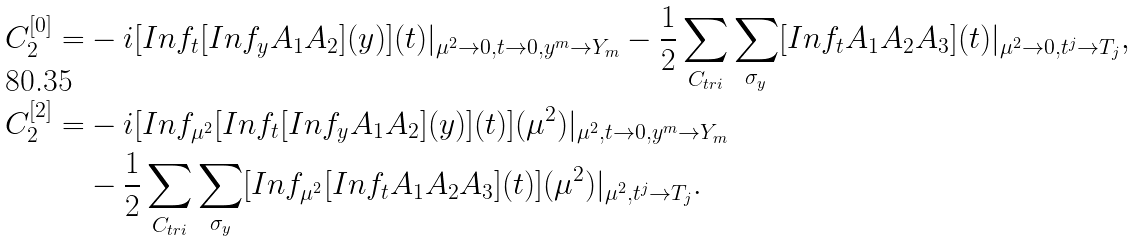<formula> <loc_0><loc_0><loc_500><loc_500>C _ { 2 } ^ { [ 0 ] } = & - i [ I n f _ { t } [ I n f _ { y } A _ { 1 } A _ { 2 } ] ( y ) ] ( t ) | _ { \mu ^ { 2 } \rightarrow 0 , t \rightarrow 0 , y ^ { m } \rightarrow Y _ { m } } - \frac { 1 } { 2 } \sum _ { C _ { t r i } } \sum _ { \sigma _ { y } } [ I n f _ { t } A _ { 1 } A _ { 2 } A _ { 3 } ] ( t ) | _ { \mu ^ { 2 } \rightarrow 0 , t ^ { j } \rightarrow T _ { j } } , \\ C _ { 2 } ^ { [ 2 ] } = & - i [ I n f _ { \mu ^ { 2 } } [ I n f _ { t } [ I n f _ { y } A _ { 1 } A _ { 2 } ] ( y ) ] ( t ) ] ( \mu ^ { 2 } ) | _ { \mu ^ { 2 } , t \rightarrow 0 , y ^ { m } \rightarrow Y _ { m } } \\ & - \frac { 1 } { 2 } \sum _ { C _ { t r i } } \sum _ { \sigma _ { y } } [ I n f _ { \mu ^ { 2 } } [ I n f _ { t } A _ { 1 } A _ { 2 } A _ { 3 } ] ( t ) ] ( \mu ^ { 2 } ) | _ { \mu ^ { 2 } , t ^ { j } \rightarrow T _ { j } } .</formula> 